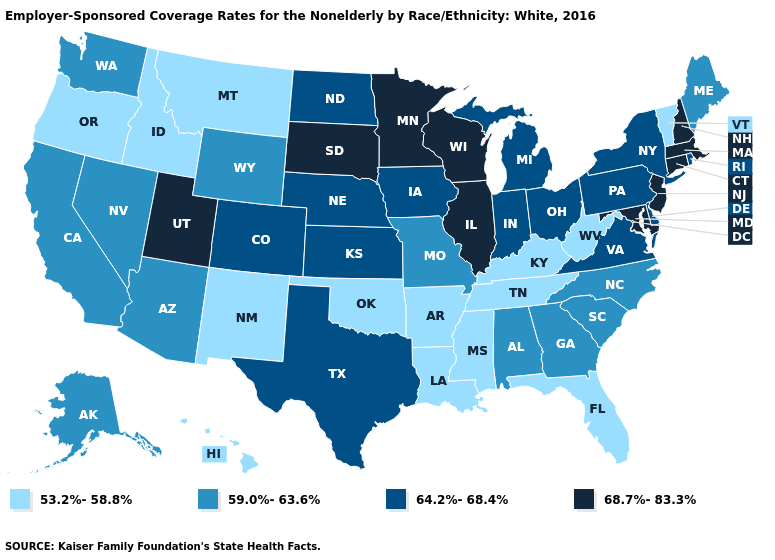Which states have the highest value in the USA?
Answer briefly. Connecticut, Illinois, Maryland, Massachusetts, Minnesota, New Hampshire, New Jersey, South Dakota, Utah, Wisconsin. Which states have the lowest value in the Northeast?
Give a very brief answer. Vermont. Does Alaska have the same value as North Dakota?
Write a very short answer. No. What is the value of Texas?
Write a very short answer. 64.2%-68.4%. Which states have the lowest value in the West?
Quick response, please. Hawaii, Idaho, Montana, New Mexico, Oregon. Name the states that have a value in the range 53.2%-58.8%?
Be succinct. Arkansas, Florida, Hawaii, Idaho, Kentucky, Louisiana, Mississippi, Montana, New Mexico, Oklahoma, Oregon, Tennessee, Vermont, West Virginia. Does Alabama have a higher value than Florida?
Answer briefly. Yes. Does Washington have the same value as Wyoming?
Concise answer only. Yes. Which states hav the highest value in the MidWest?
Short answer required. Illinois, Minnesota, South Dakota, Wisconsin. Which states have the lowest value in the USA?
Short answer required. Arkansas, Florida, Hawaii, Idaho, Kentucky, Louisiana, Mississippi, Montana, New Mexico, Oklahoma, Oregon, Tennessee, Vermont, West Virginia. Name the states that have a value in the range 59.0%-63.6%?
Be succinct. Alabama, Alaska, Arizona, California, Georgia, Maine, Missouri, Nevada, North Carolina, South Carolina, Washington, Wyoming. What is the value of Missouri?
Write a very short answer. 59.0%-63.6%. What is the value of Louisiana?
Short answer required. 53.2%-58.8%. Name the states that have a value in the range 59.0%-63.6%?
Answer briefly. Alabama, Alaska, Arizona, California, Georgia, Maine, Missouri, Nevada, North Carolina, South Carolina, Washington, Wyoming. Does Nebraska have the lowest value in the MidWest?
Quick response, please. No. 